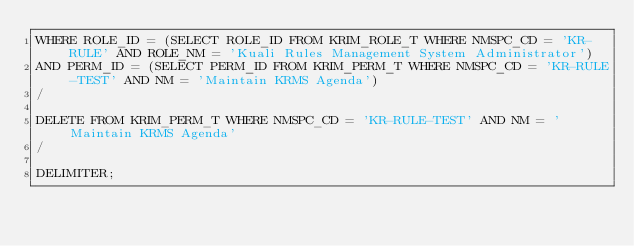<code> <loc_0><loc_0><loc_500><loc_500><_SQL_>WHERE ROLE_ID = (SELECT ROLE_ID FROM KRIM_ROLE_T WHERE NMSPC_CD = 'KR-RULE' AND ROLE_NM = 'Kuali Rules Management System Administrator')
AND PERM_ID = (SELECT PERM_ID FROM KRIM_PERM_T WHERE NMSPC_CD = 'KR-RULE-TEST' AND NM = 'Maintain KRMS Agenda')
/

DELETE FROM KRIM_PERM_T WHERE NMSPC_CD = 'KR-RULE-TEST' AND NM = 'Maintain KRMS Agenda'
/

DELIMITER;</code> 